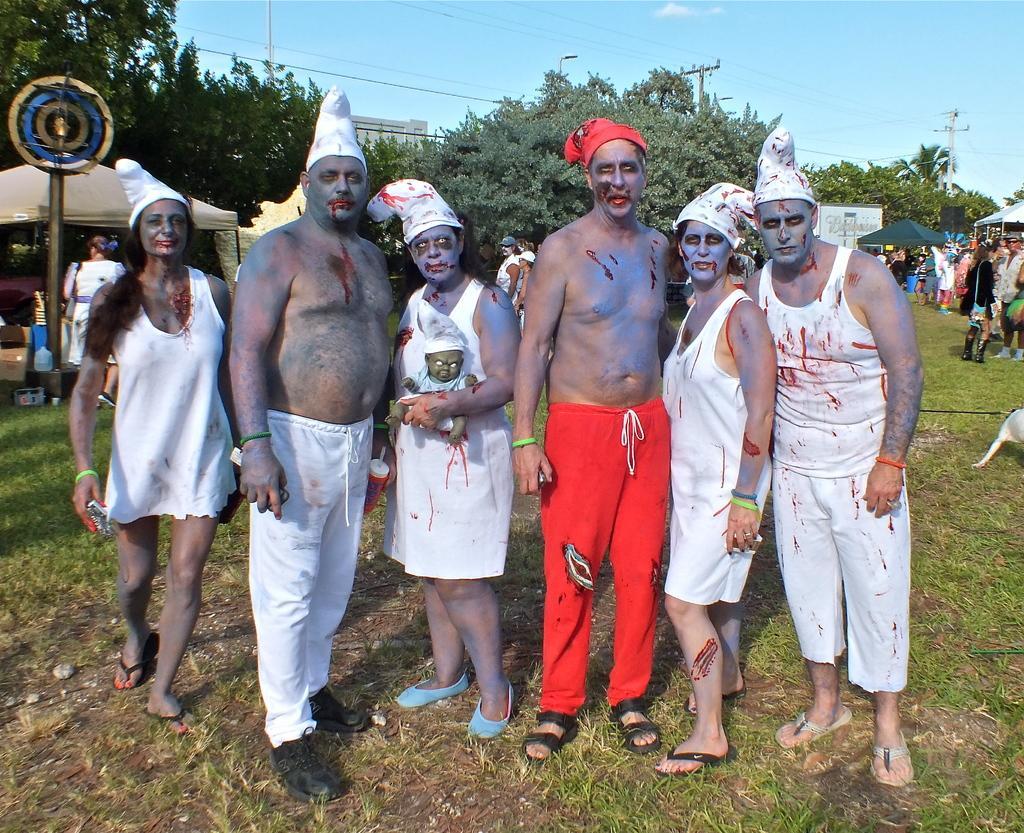Can you describe this image briefly? In this image, we can see a few people with different costumes. We can see the ground covered with grass. We can also see some trees, poles, wires and umbrellas. We can also see the sky. We can also see a board. 